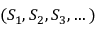Convert formula to latex. <formula><loc_0><loc_0><loc_500><loc_500>( S _ { 1 } , S _ { 2 } , S _ { 3 } , \dots )</formula> 